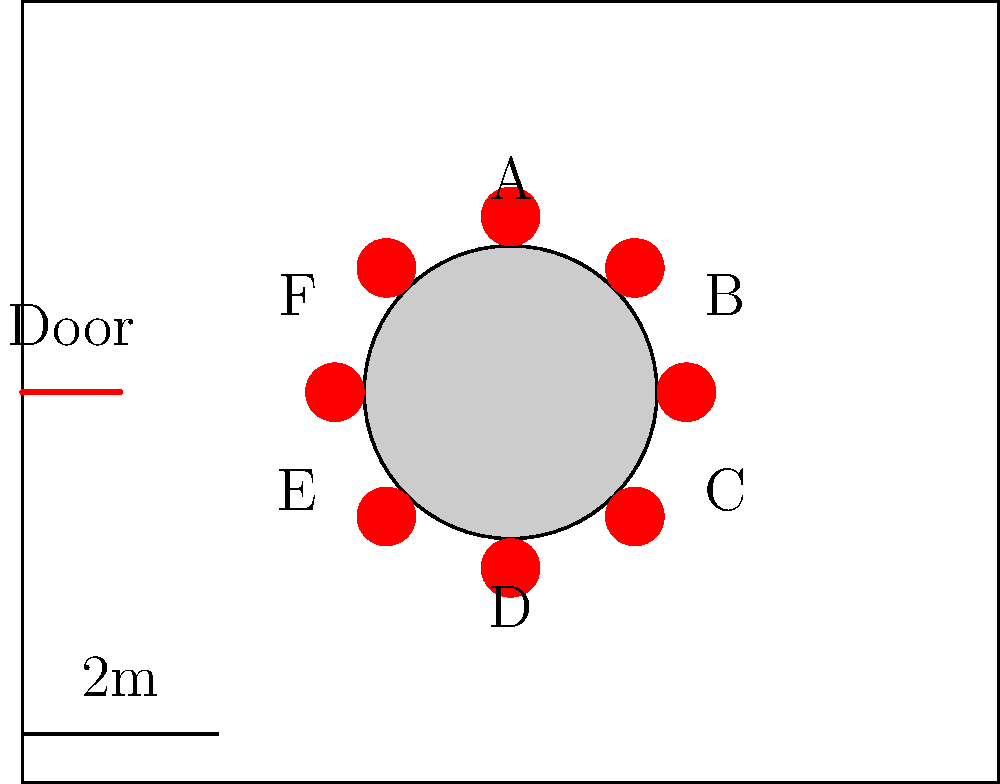In the given floor plan of an underground poker room, there are 6 potential seating positions (A-F) around the table. Considering that the organizer wants to maximize the distance between players and the door for security reasons, which two positions should be reserved for the most important players? To determine the optimal seating arrangement for the most important players, we need to consider the distance from each seat to the door. The farther from the door, the better for security reasons.

Step 1: Identify the door location
The door is located on the left side of the room.

Step 2: Estimate distances from each seat to the door
A: Moderate distance
B: Far distance
C: Far distance
D: Moderate to far distance
E: Close distance
F: Close distance

Step 3: Compare distances
The seats farthest from the door are B and C.

Step 4: Consider additional factors
Both B and C are on the opposite side of the room from the door, providing maximum distance and potentially obstructed view from the entrance.

Step 5: Make the final decision
The two positions that should be reserved for the most important players are B and C, as they provide the maximum distance from the door and the best security.
Answer: B and C 